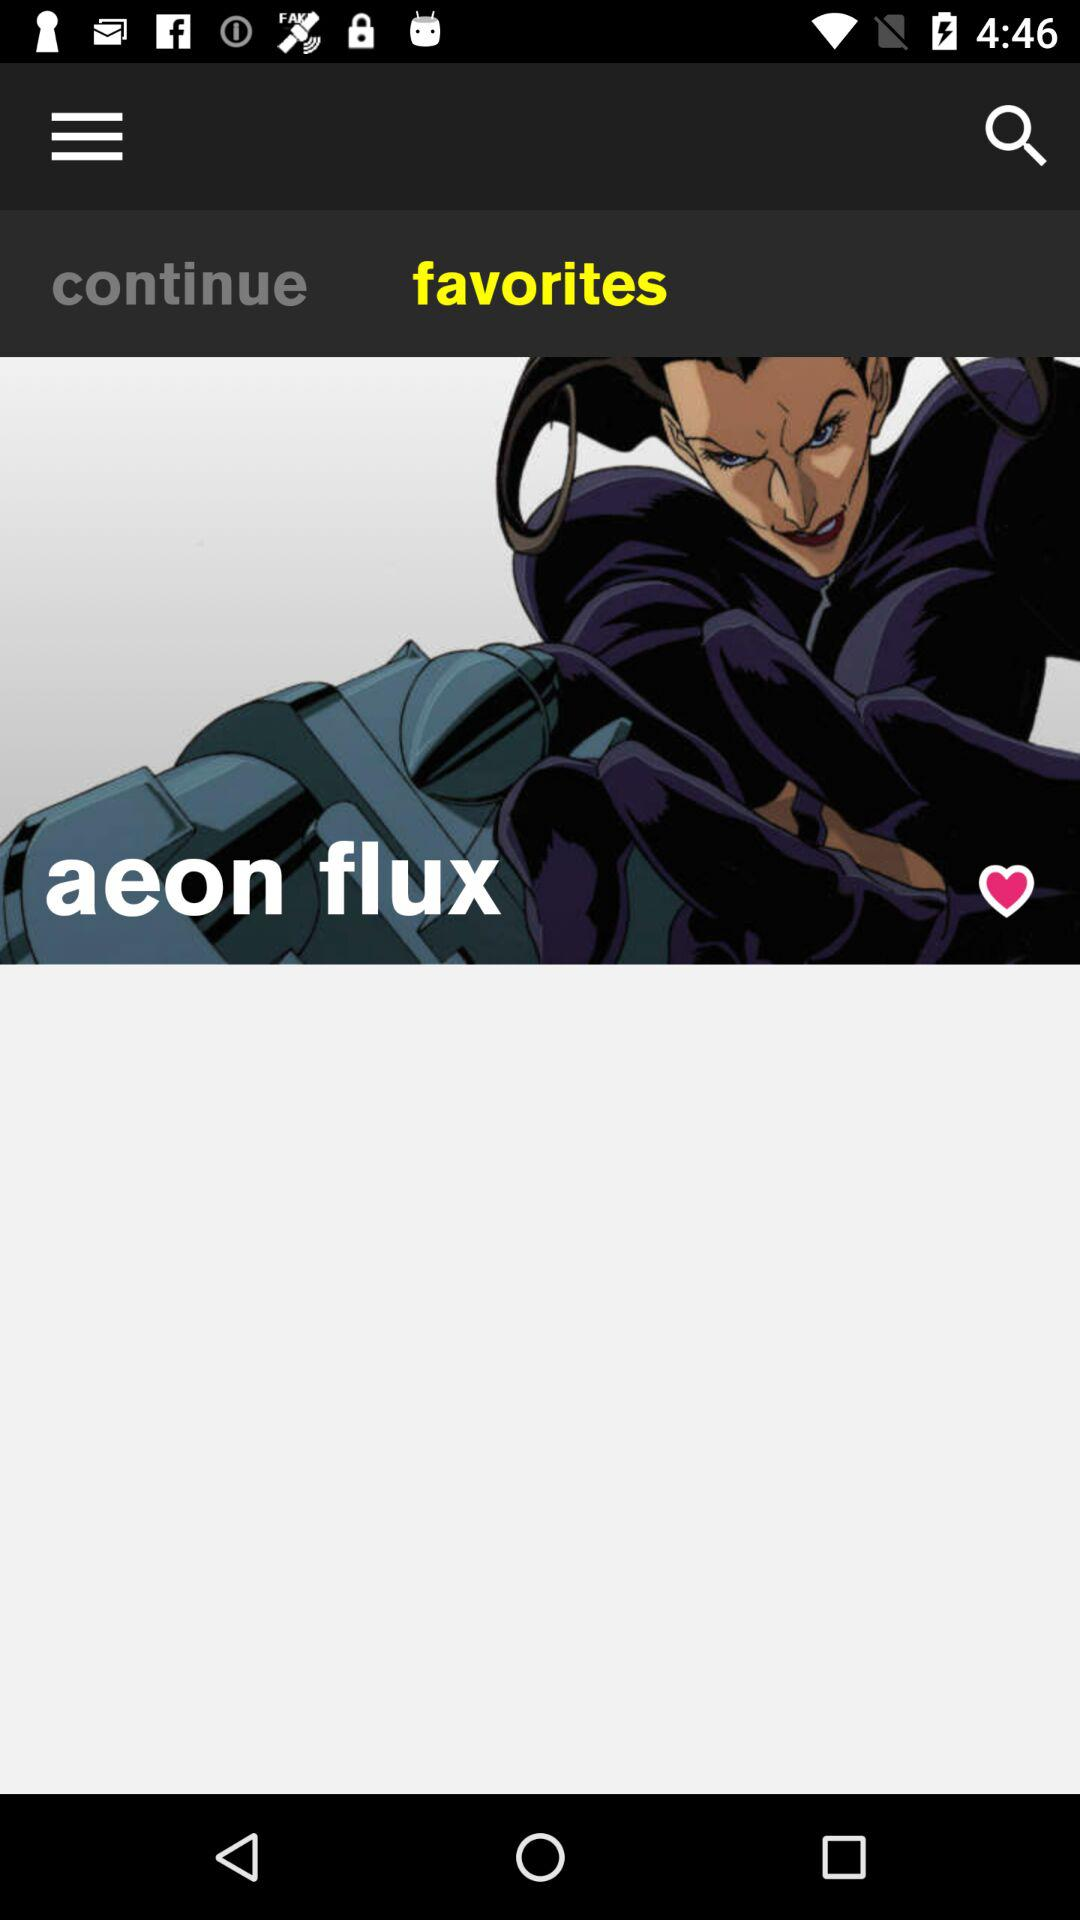How many likes does "aeon flux" have?
When the provided information is insufficient, respond with <no answer>. <no answer> 